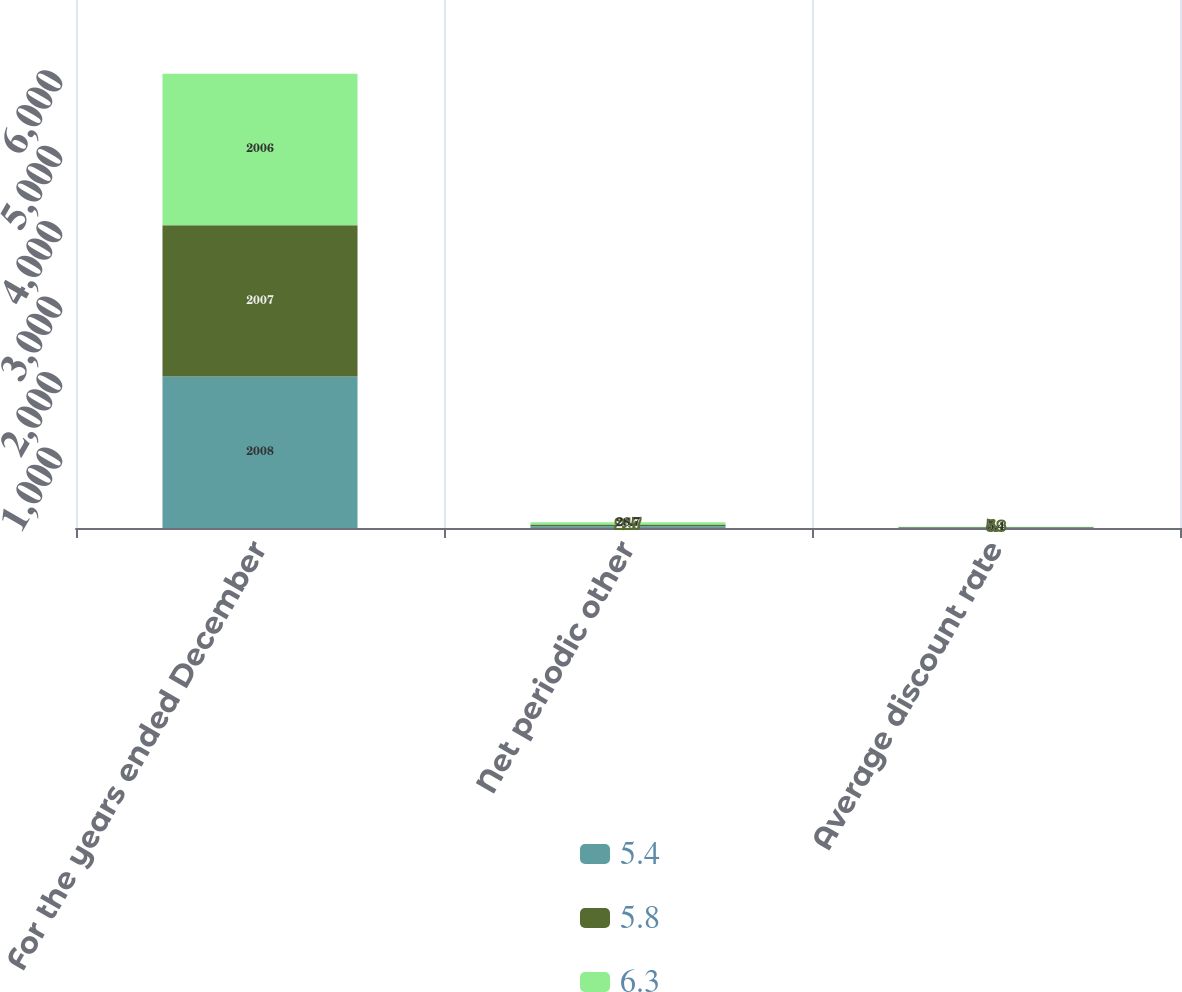Convert chart. <chart><loc_0><loc_0><loc_500><loc_500><stacked_bar_chart><ecel><fcel>For the years ended December<fcel>Net periodic other<fcel>Average discount rate<nl><fcel>5.4<fcel>2008<fcel>21.6<fcel>6.3<nl><fcel>5.8<fcel>2007<fcel>24.7<fcel>5.8<nl><fcel>6.3<fcel>2006<fcel>28.7<fcel>5.4<nl></chart> 